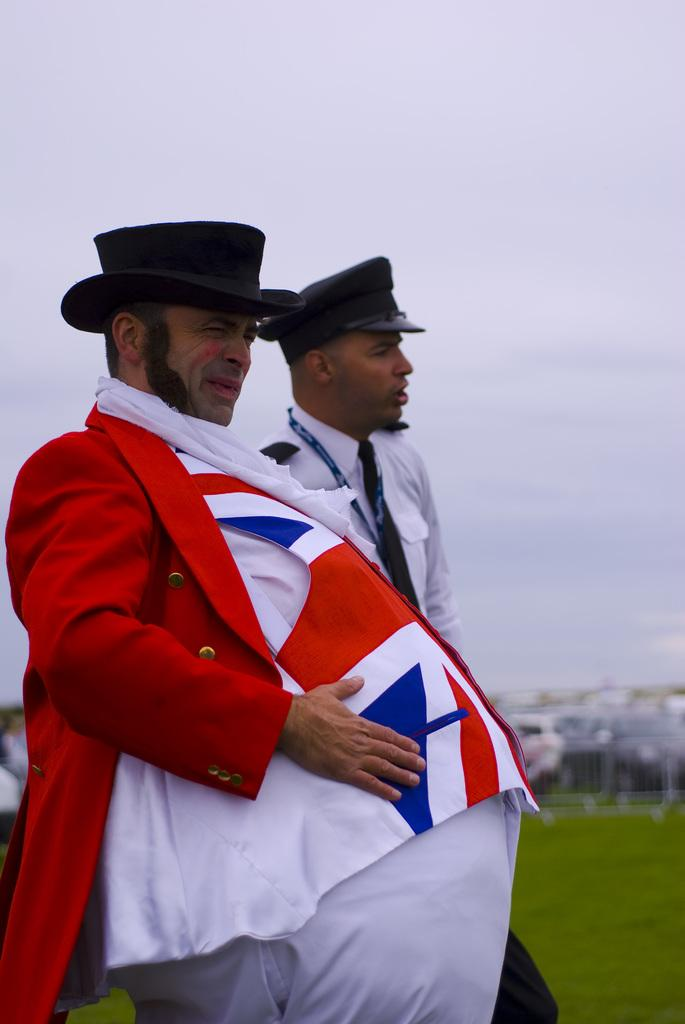How many people are in the image? There are two persons in the image. What are the persons wearing on their heads? The persons are wearing caps. What type of terrain is visible in the image? There is grass visible in the image. What can be seen in the background of the image? There is sky visible in the background of the image. What is the condition of the sky in the image? Clouds are present in the sky. What type of needle can be seen in the image? There is no needle present in the image. What kind of crack is visible on the person's face in the image? There are no cracks or any indication of damage on the persons' faces in the image. 